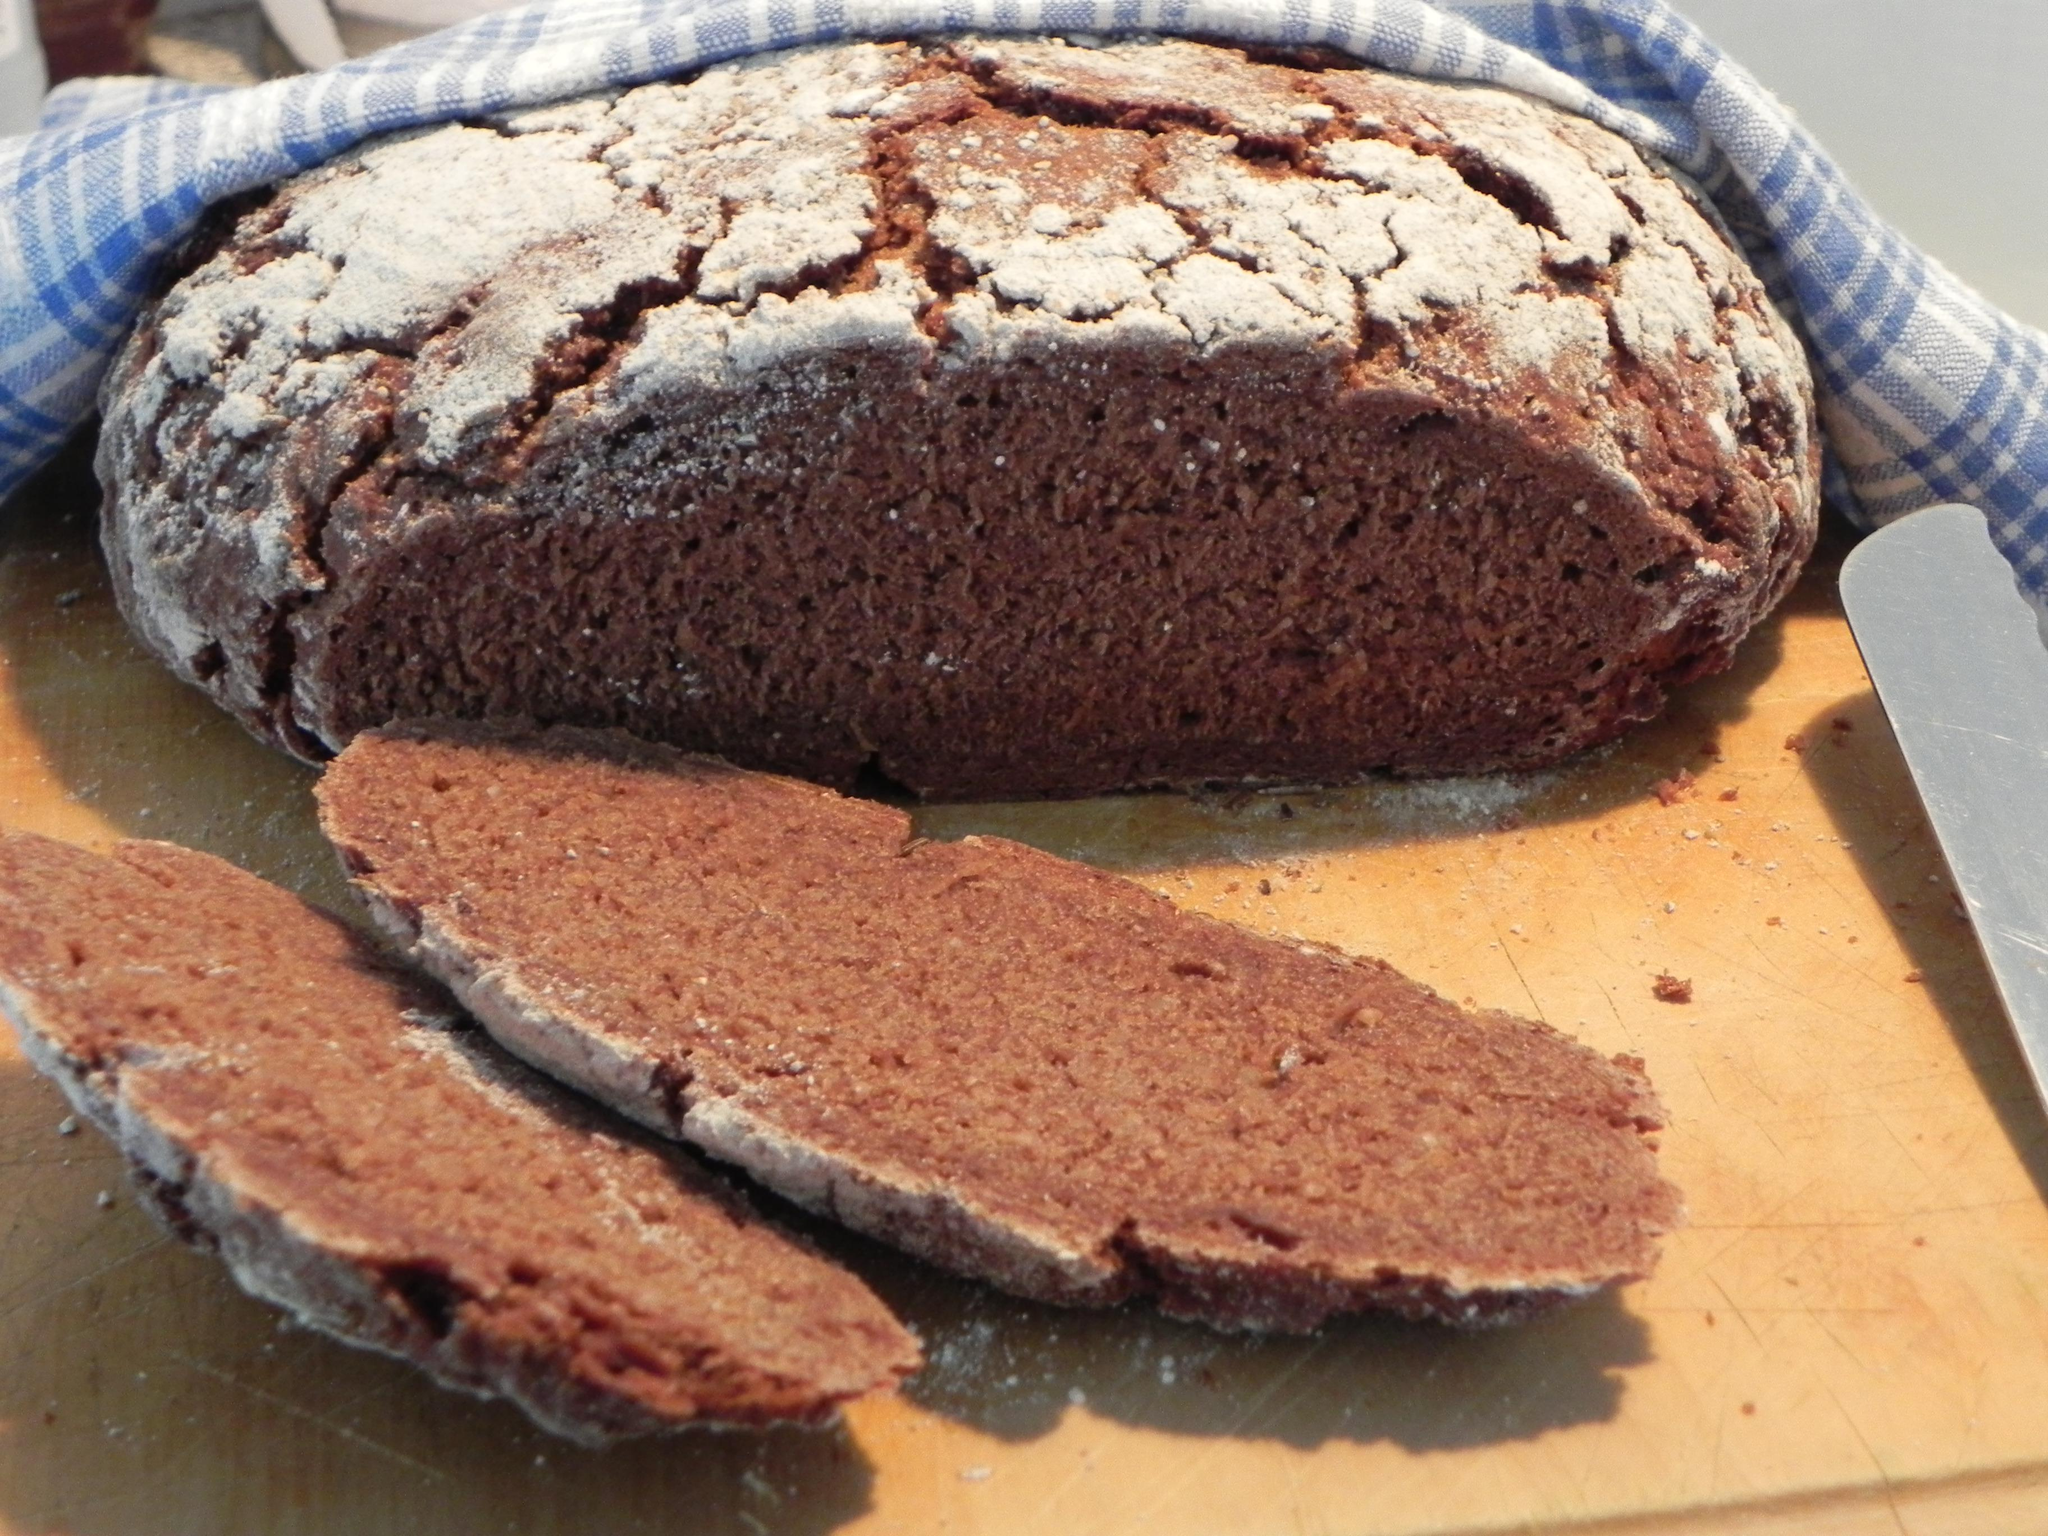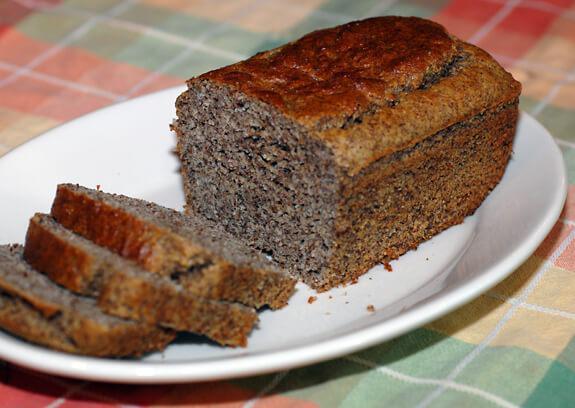The first image is the image on the left, the second image is the image on the right. For the images displayed, is the sentence "None of the bread is cut in at least one of the images." factually correct? Answer yes or no. No. The first image is the image on the left, the second image is the image on the right. For the images shown, is this caption "One of the loaves is placed in an oval dish." true? Answer yes or no. Yes. 